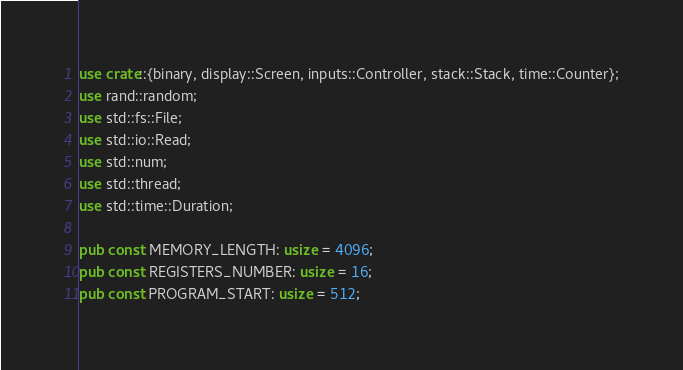Convert code to text. <code><loc_0><loc_0><loc_500><loc_500><_Rust_>use crate::{binary, display::Screen, inputs::Controller, stack::Stack, time::Counter};
use rand::random;
use std::fs::File;
use std::io::Read;
use std::num;
use std::thread;
use std::time::Duration;

pub const MEMORY_LENGTH: usize = 4096;
pub const REGISTERS_NUMBER: usize = 16;
pub const PROGRAM_START: usize = 512;
</code> 